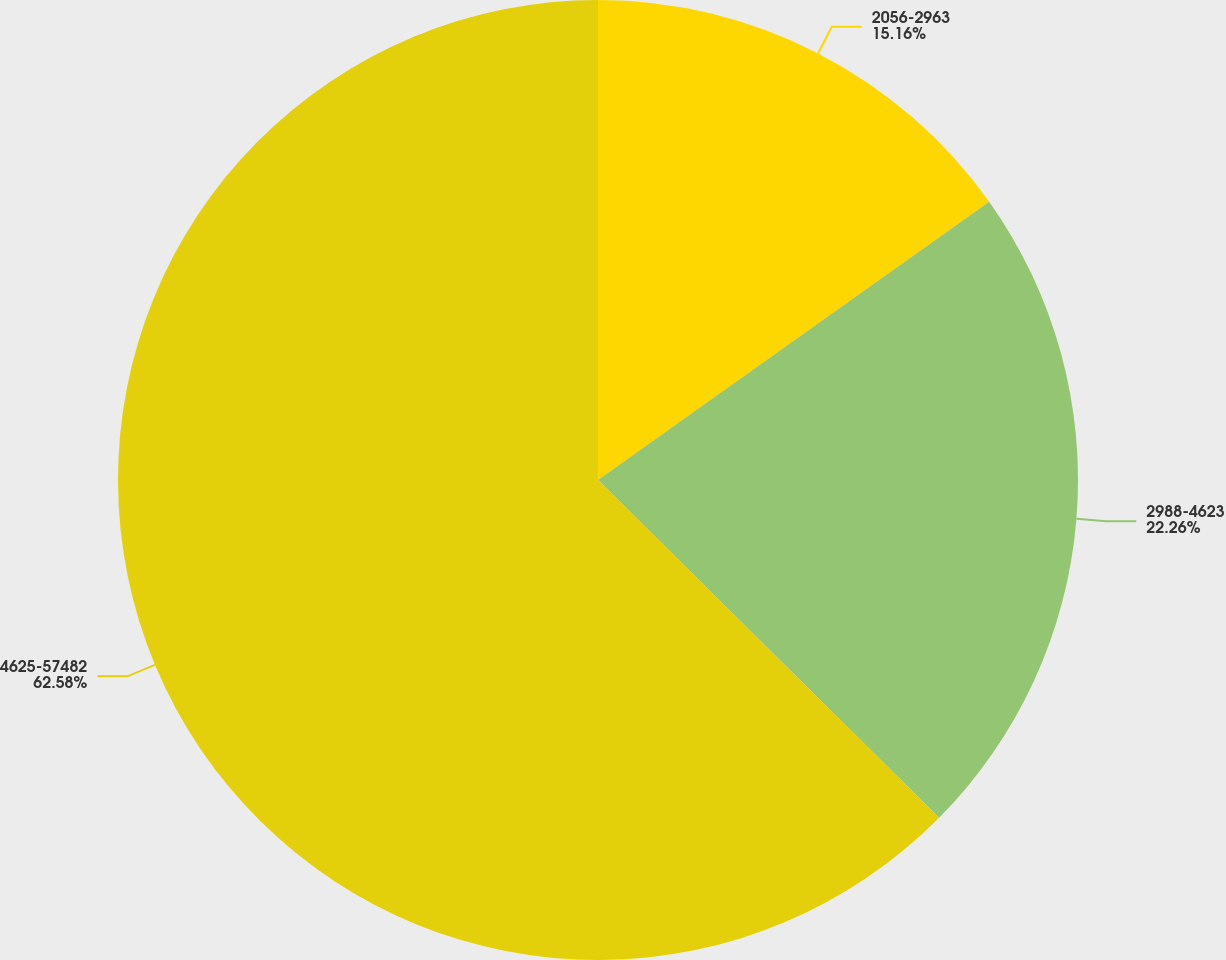Convert chart. <chart><loc_0><loc_0><loc_500><loc_500><pie_chart><fcel>2056-2963<fcel>2988-4623<fcel>4625-57482<nl><fcel>15.16%<fcel>22.26%<fcel>62.58%<nl></chart> 